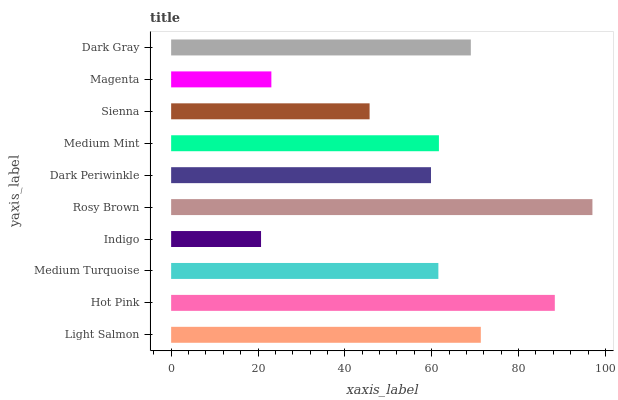Is Indigo the minimum?
Answer yes or no. Yes. Is Rosy Brown the maximum?
Answer yes or no. Yes. Is Hot Pink the minimum?
Answer yes or no. No. Is Hot Pink the maximum?
Answer yes or no. No. Is Hot Pink greater than Light Salmon?
Answer yes or no. Yes. Is Light Salmon less than Hot Pink?
Answer yes or no. Yes. Is Light Salmon greater than Hot Pink?
Answer yes or no. No. Is Hot Pink less than Light Salmon?
Answer yes or no. No. Is Medium Mint the high median?
Answer yes or no. Yes. Is Medium Turquoise the low median?
Answer yes or no. Yes. Is Dark Periwinkle the high median?
Answer yes or no. No. Is Sienna the low median?
Answer yes or no. No. 